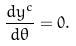Convert formula to latex. <formula><loc_0><loc_0><loc_500><loc_500>\frac { d y ^ { c } } { d \theta } = 0 .</formula> 